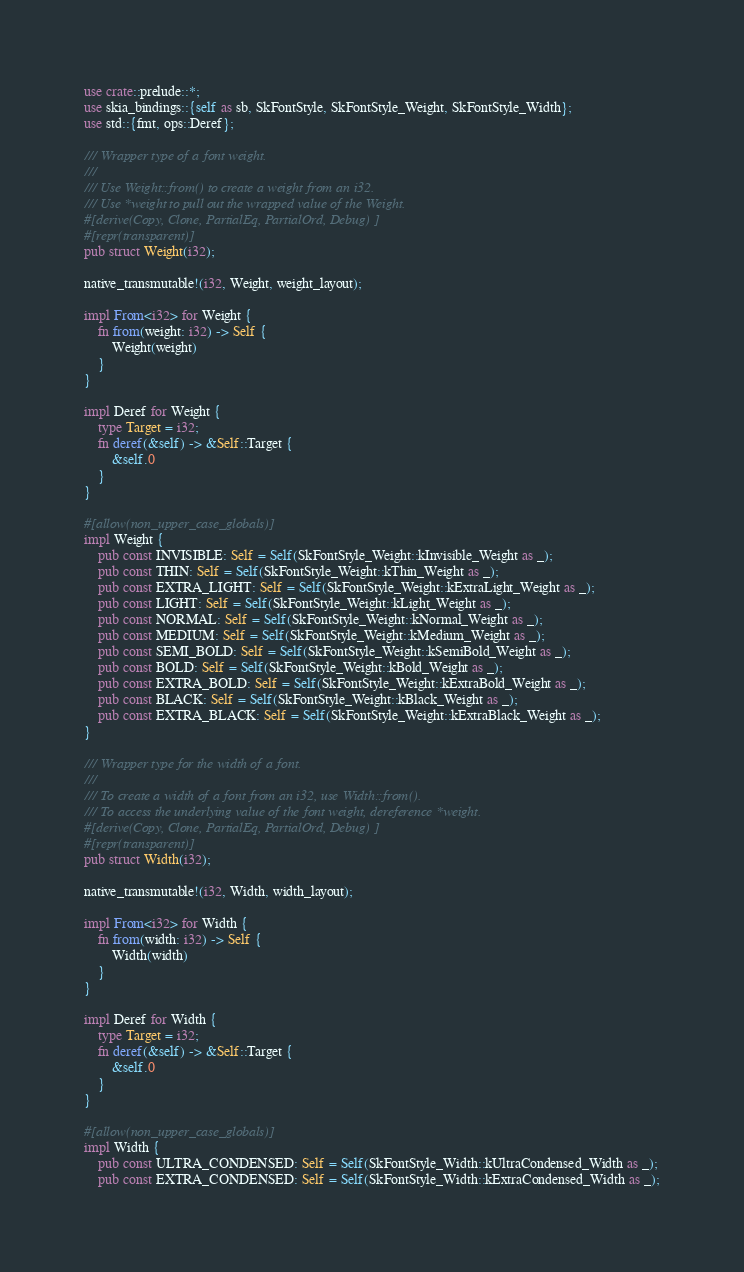Convert code to text. <code><loc_0><loc_0><loc_500><loc_500><_Rust_>use crate::prelude::*;
use skia_bindings::{self as sb, SkFontStyle, SkFontStyle_Weight, SkFontStyle_Width};
use std::{fmt, ops::Deref};

/// Wrapper type of a font weight.
///
/// Use Weight::from() to create a weight from an i32.
/// Use *weight to pull out the wrapped value of the Weight.
#[derive(Copy, Clone, PartialEq, PartialOrd, Debug)]
#[repr(transparent)]
pub struct Weight(i32);

native_transmutable!(i32, Weight, weight_layout);

impl From<i32> for Weight {
    fn from(weight: i32) -> Self {
        Weight(weight)
    }
}

impl Deref for Weight {
    type Target = i32;
    fn deref(&self) -> &Self::Target {
        &self.0
    }
}

#[allow(non_upper_case_globals)]
impl Weight {
    pub const INVISIBLE: Self = Self(SkFontStyle_Weight::kInvisible_Weight as _);
    pub const THIN: Self = Self(SkFontStyle_Weight::kThin_Weight as _);
    pub const EXTRA_LIGHT: Self = Self(SkFontStyle_Weight::kExtraLight_Weight as _);
    pub const LIGHT: Self = Self(SkFontStyle_Weight::kLight_Weight as _);
    pub const NORMAL: Self = Self(SkFontStyle_Weight::kNormal_Weight as _);
    pub const MEDIUM: Self = Self(SkFontStyle_Weight::kMedium_Weight as _);
    pub const SEMI_BOLD: Self = Self(SkFontStyle_Weight::kSemiBold_Weight as _);
    pub const BOLD: Self = Self(SkFontStyle_Weight::kBold_Weight as _);
    pub const EXTRA_BOLD: Self = Self(SkFontStyle_Weight::kExtraBold_Weight as _);
    pub const BLACK: Self = Self(SkFontStyle_Weight::kBlack_Weight as _);
    pub const EXTRA_BLACK: Self = Self(SkFontStyle_Weight::kExtraBlack_Weight as _);
}

/// Wrapper type for the width of a font.
///
/// To create a width of a font from an i32, use Width::from().
/// To access the underlying value of the font weight, dereference *weight.
#[derive(Copy, Clone, PartialEq, PartialOrd, Debug)]
#[repr(transparent)]
pub struct Width(i32);

native_transmutable!(i32, Width, width_layout);

impl From<i32> for Width {
    fn from(width: i32) -> Self {
        Width(width)
    }
}

impl Deref for Width {
    type Target = i32;
    fn deref(&self) -> &Self::Target {
        &self.0
    }
}

#[allow(non_upper_case_globals)]
impl Width {
    pub const ULTRA_CONDENSED: Self = Self(SkFontStyle_Width::kUltraCondensed_Width as _);
    pub const EXTRA_CONDENSED: Self = Self(SkFontStyle_Width::kExtraCondensed_Width as _);</code> 